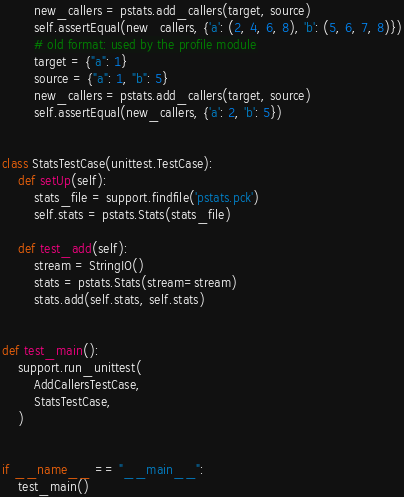<code> <loc_0><loc_0><loc_500><loc_500><_Python_>        new_callers = pstats.add_callers(target, source)
        self.assertEqual(new_callers, {'a': (2, 4, 6, 8), 'b': (5, 6, 7, 8)})
        # old format: used by the profile module
        target = {"a": 1}
        source = {"a": 1, "b": 5}
        new_callers = pstats.add_callers(target, source)
        self.assertEqual(new_callers, {'a': 2, 'b': 5})


class StatsTestCase(unittest.TestCase):
    def setUp(self):
        stats_file = support.findfile('pstats.pck')
        self.stats = pstats.Stats(stats_file)

    def test_add(self):
        stream = StringIO()
        stats = pstats.Stats(stream=stream)
        stats.add(self.stats, self.stats)


def test_main():
    support.run_unittest(
        AddCallersTestCase,
        StatsTestCase,
    )


if __name__ == "__main__":
    test_main()
</code> 